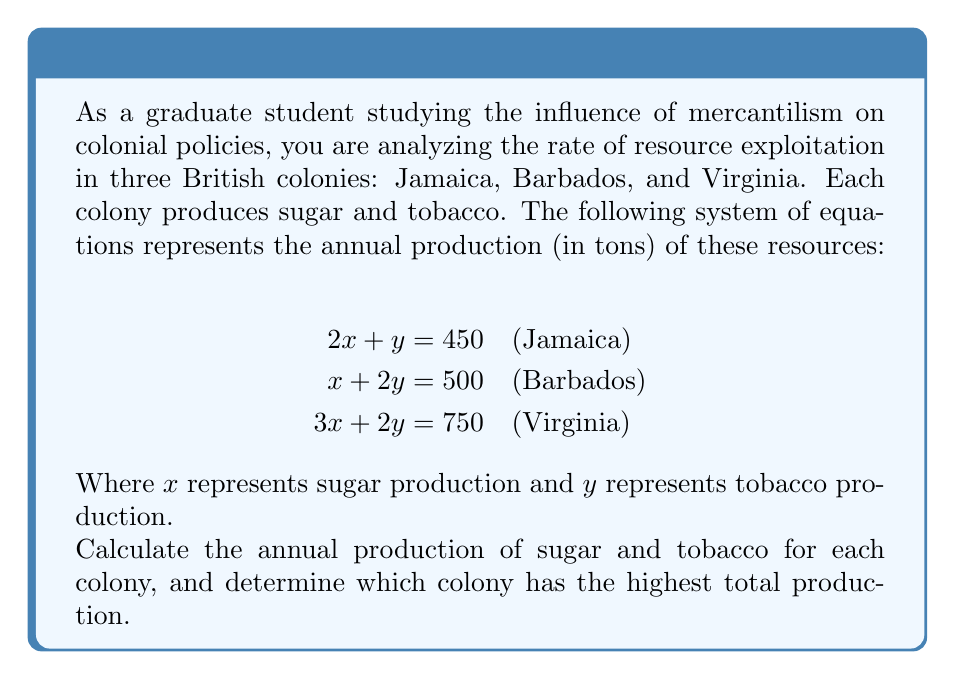Can you solve this math problem? To solve this system of equations, we'll use the elimination method:

1. Multiply the first equation by 2 and the second equation by -1:
   $$\begin{aligned}
   4x + 2y &= 900 \\
   -x - 2y &= -500
   \end{aligned}$$

2. Add these equations to eliminate $y$:
   $$3x = 400$$

3. Solve for $x$:
   $$x = \frac{400}{3} \approx 133.33$$

4. Substitute this value of $x$ into the first equation to solve for $y$:
   $$\begin{aligned}
   2(133.33) + y &= 450 \\
   266.67 + y &= 450 \\
   y &= 183.33
   \end{aligned}$$

5. Now we have $x \approx 133.33$ (sugar) and $y \approx 183.33$ (tobacco).

6. Calculate the production for each colony:
   Jamaica: $2(133.33) + 183.33 = 450$
   Barbados: $133.33 + 2(183.33) = 500$
   Virginia: $3(133.33) + 2(183.33) = 750$

7. To determine which colony has the highest total production, we compare:
   Jamaica: 450 tons
   Barbados: 500 tons
   Virginia: 750 tons

Virginia has the highest total production.
Answer: Sugar production (x): 133.33 tons
Tobacco production (y): 183.33 tons

Jamaica: 266.67 tons of sugar, 183.33 tons of tobacco
Barbados: 133.33 tons of sugar, 366.67 tons of tobacco
Virginia: 400 tons of sugar, 350 tons of tobacco

Virginia has the highest total production at 750 tons. 